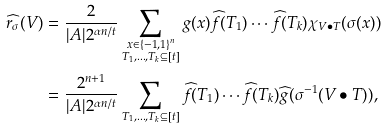Convert formula to latex. <formula><loc_0><loc_0><loc_500><loc_500>\widehat { r _ { \sigma } } ( V ) & = \frac { 2 } { | A | 2 ^ { \alpha n / t } } \sum _ { \substack { x \in \{ - 1 , 1 \} ^ { n } \\ T _ { 1 } , \dots , T _ { k } \subseteq [ t ] } } g ( x ) \widehat { f } ( T _ { 1 } ) \cdots \widehat { f } ( T _ { k } ) \chi _ { V \bullet T } ( \sigma ( x ) ) \\ & = \frac { 2 ^ { n + 1 } } { | A | 2 ^ { \alpha n / t } } \sum _ { T _ { 1 } , \dots , T _ { k } \subseteq [ t ] } \widehat { f } ( T _ { 1 } ) \cdots \widehat { f } ( T _ { k } ) \widehat { g } ( \sigma ^ { - 1 } ( V \bullet T ) ) ,</formula> 